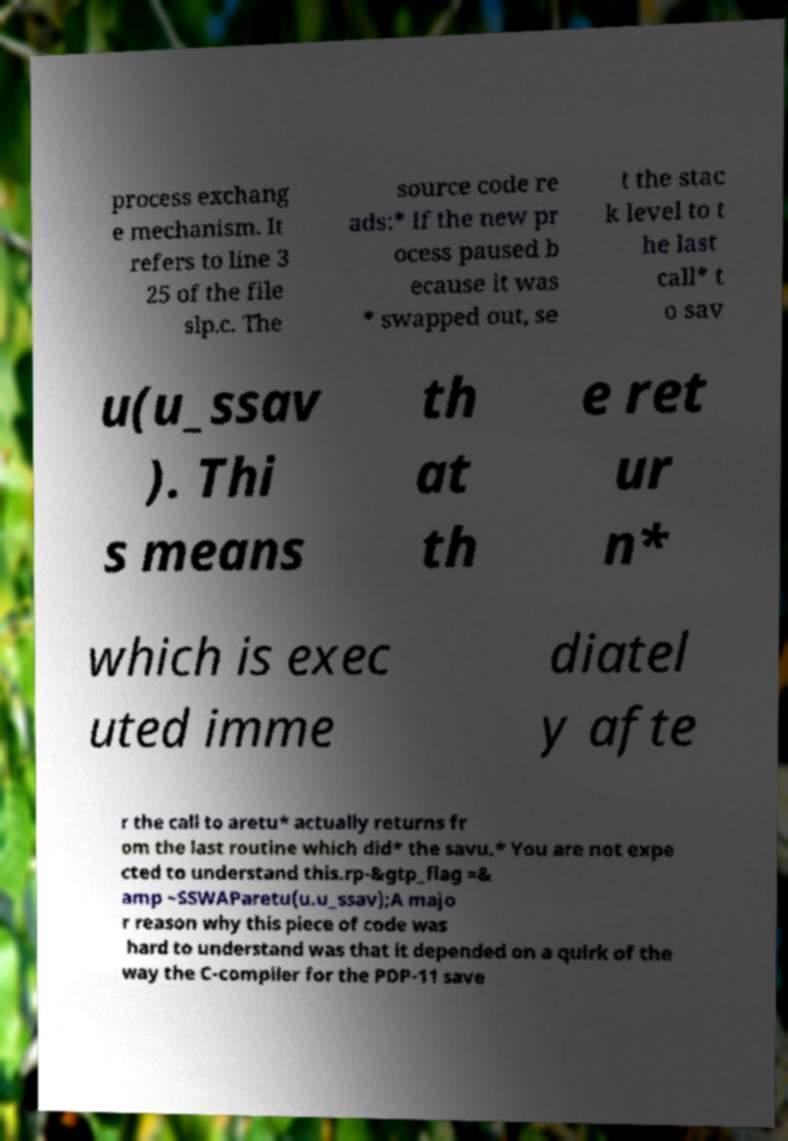For documentation purposes, I need the text within this image transcribed. Could you provide that? process exchang e mechanism. It refers to line 3 25 of the file slp.c. The source code re ads:* If the new pr ocess paused b ecause it was * swapped out, se t the stac k level to t he last call* t o sav u(u_ssav ). Thi s means th at th e ret ur n* which is exec uted imme diatel y afte r the call to aretu* actually returns fr om the last routine which did* the savu.* You are not expe cted to understand this.rp-&gtp_flag =& amp ~SSWAParetu(u.u_ssav);A majo r reason why this piece of code was hard to understand was that it depended on a quirk of the way the C-compiler for the PDP-11 save 